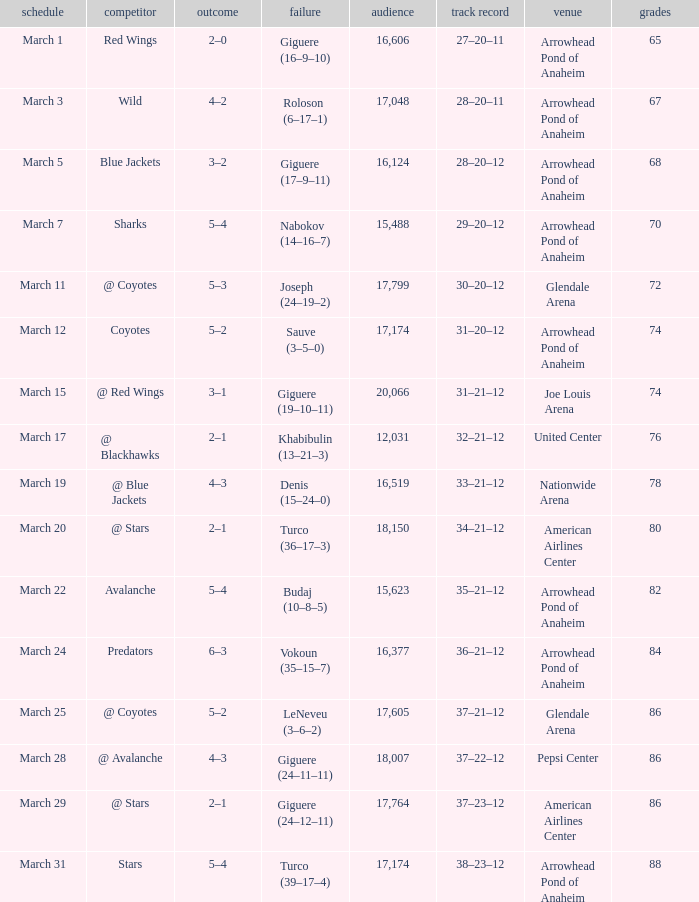What is the Record of the game with an Attendance of more than 16,124 and a Score of 6–3? 36–21–12. 